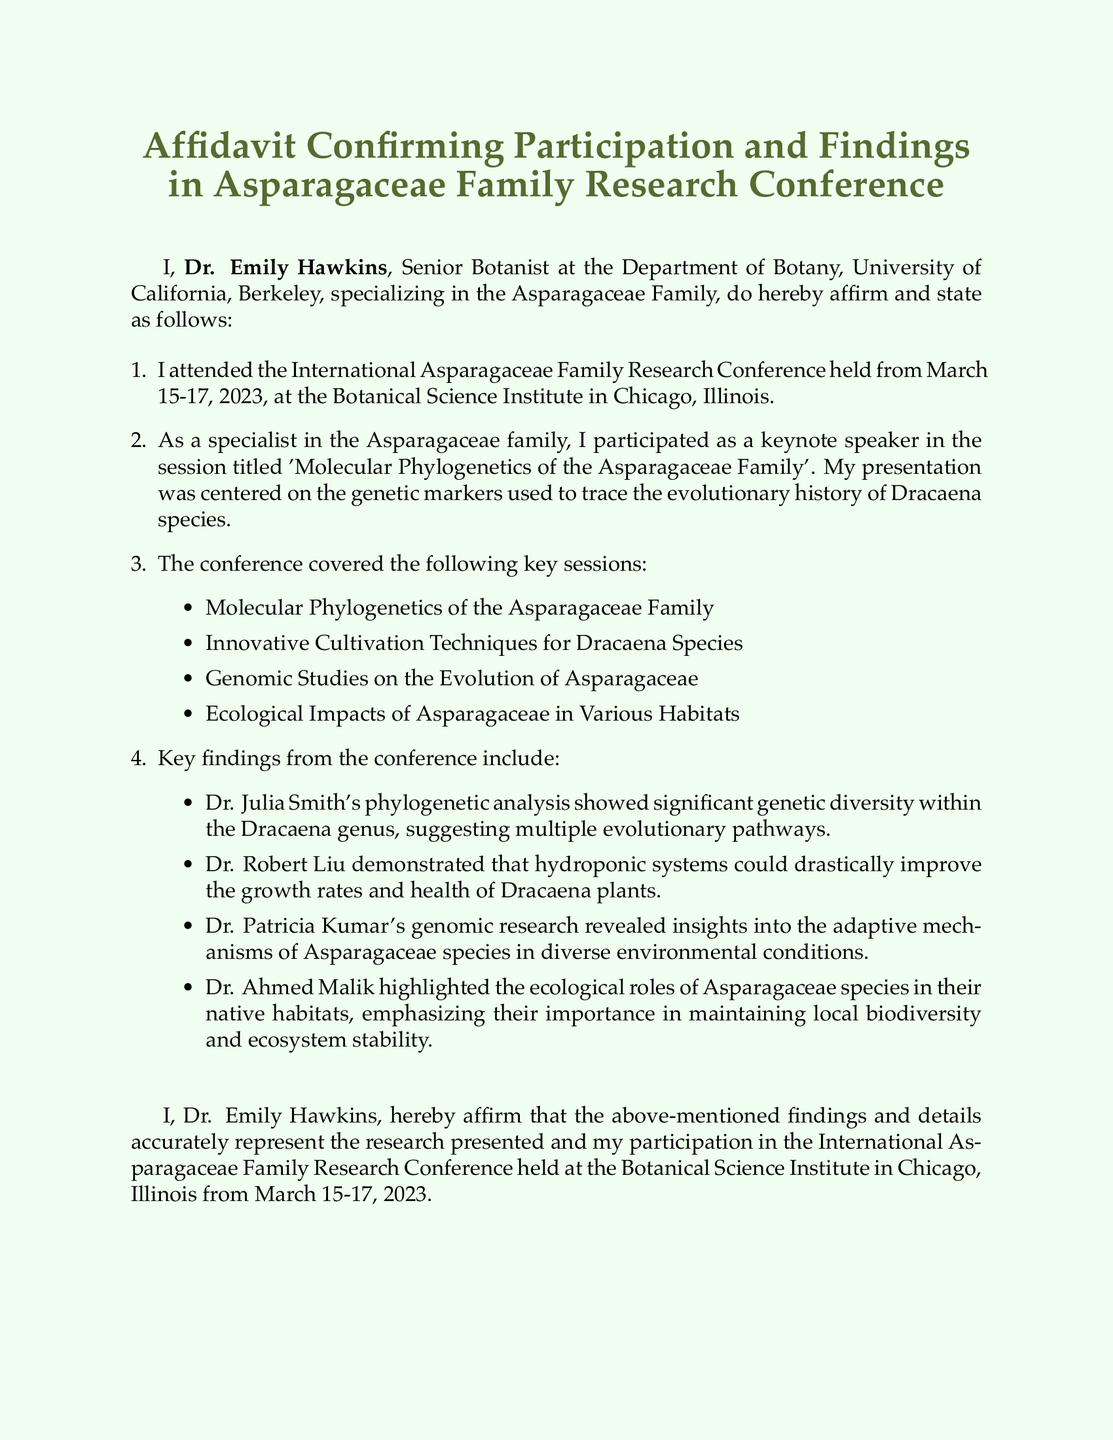What is the name of the person affirming the affidavit? The name of the person affirming the affidavit is stated at the beginning of the document.
Answer: Dr. Emily Hawkins What was the location of the conference? The document specifies the location of the conference in one of the bullet points.
Answer: Chicago, Illinois What were the dates of the conference? The dates are clearly mentioned at the start of the document.
Answer: March 15-17, 2023 What session did Dr. Emily Hawkins participate in? The specific session is outlined in one of the enumerated items in the document.
Answer: Molecular Phylogenetics of the Asparagaceae Family Which researcher discussed hydroponic systems? The document lists key findings from the conference, including who discussed various topics.
Answer: Dr. Robert Liu What was a key finding related to Dracaena species? The key findings are summarized in the document and include multiple aspects related to Dracaena.
Answer: Significant genetic diversity How many key sessions were listed in the conference? The number of sessions can be counted from the bulleted list provided in the document.
Answer: Four What is the professional title of Dr. Emily Hawkins? The document mentions her title in the closing section.
Answer: Senior Botanist What department is Dr. Emily Hawkins affiliated with? This information is provided at the end of the affidavit.
Answer: Department of Botany 